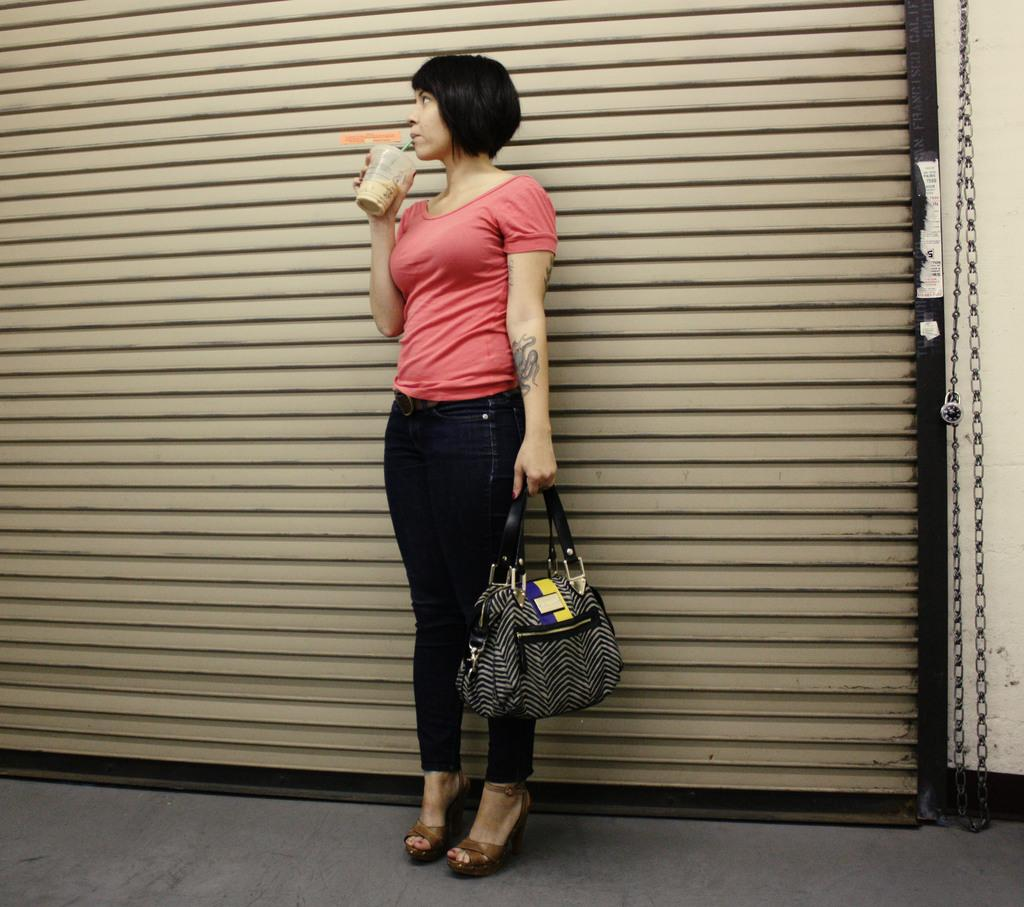What is the main subject of the image? The main subject of the image is a woman. What is the woman doing in the image? The woman is standing in the image. What objects is the woman holding in the image? The woman is holding a glass and a bag in the image. What type of rod is the woman using to perform the operation in the image? There is no rod or operation present in the image. What type of wax is the woman applying to the surface in the image? There is no wax or surface being treated in the image. 